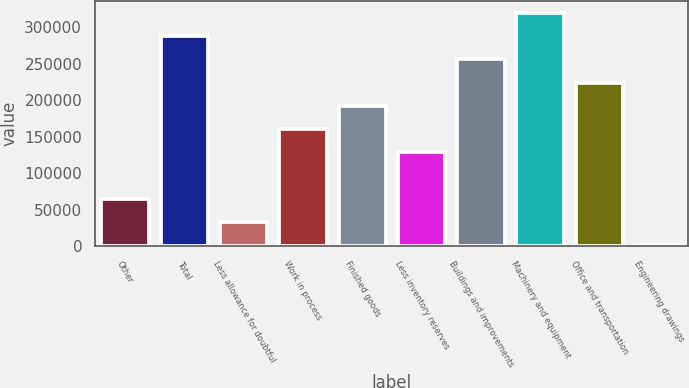<chart> <loc_0><loc_0><loc_500><loc_500><bar_chart><fcel>Other<fcel>Total<fcel>Less allowance for doubtful<fcel>Work in process<fcel>Finished goods<fcel>Less inventory reserves<fcel>Buildings and improvements<fcel>Machinery and equipment<fcel>Office and transportation<fcel>Engineering drawings<nl><fcel>65056.6<fcel>287659<fcel>33256.3<fcel>160458<fcel>192258<fcel>128657<fcel>255858<fcel>319459<fcel>224058<fcel>1456<nl></chart> 